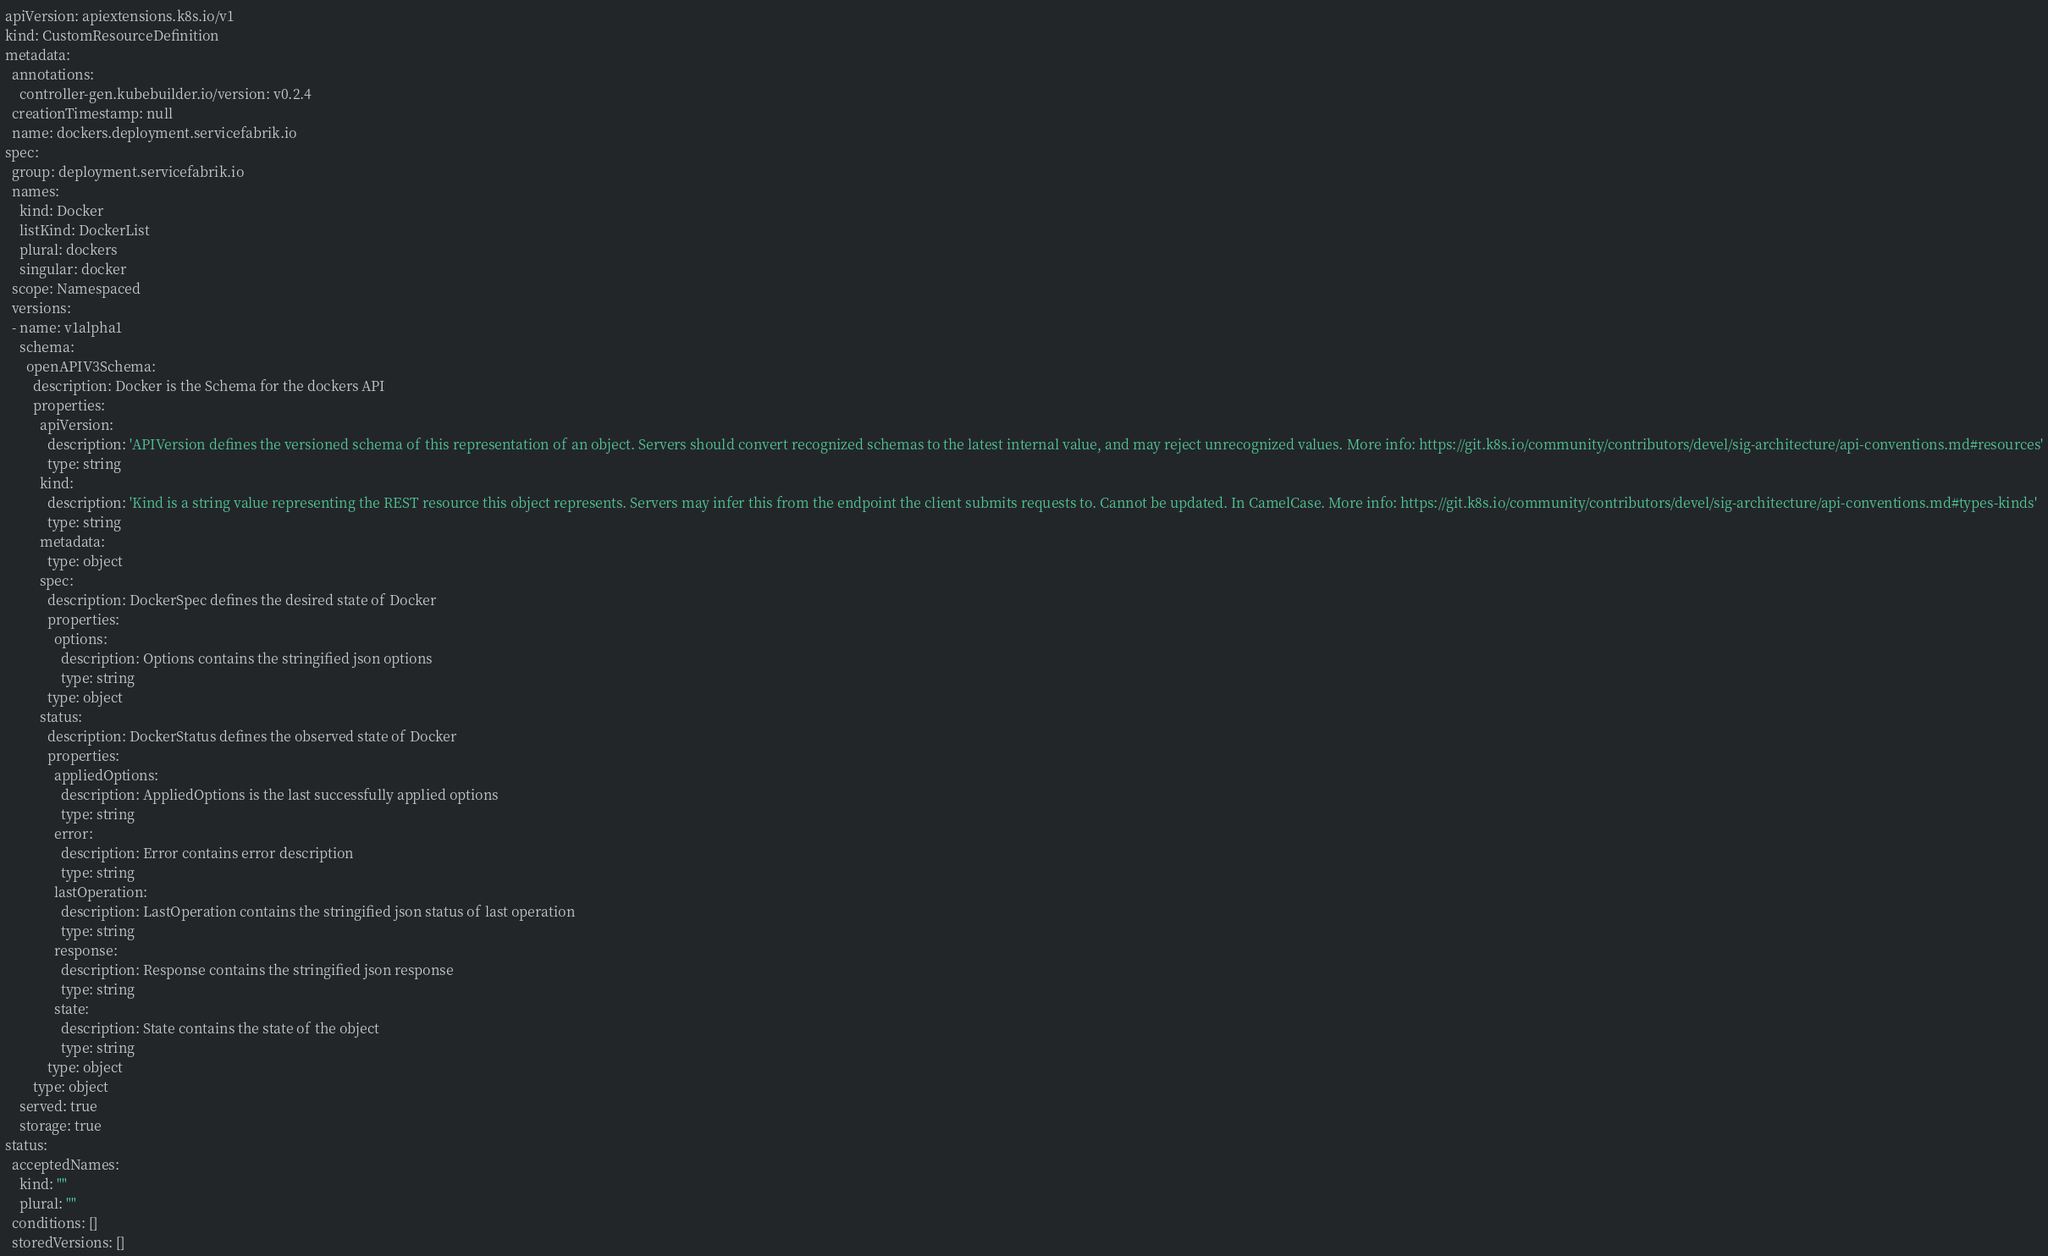Convert code to text. <code><loc_0><loc_0><loc_500><loc_500><_YAML_>apiVersion: apiextensions.k8s.io/v1
kind: CustomResourceDefinition
metadata:
  annotations:
    controller-gen.kubebuilder.io/version: v0.2.4
  creationTimestamp: null
  name: dockers.deployment.servicefabrik.io
spec:
  group: deployment.servicefabrik.io
  names:
    kind: Docker
    listKind: DockerList
    plural: dockers
    singular: docker
  scope: Namespaced
  versions:
  - name: v1alpha1
    schema:
      openAPIV3Schema:
        description: Docker is the Schema for the dockers API
        properties:
          apiVersion:
            description: 'APIVersion defines the versioned schema of this representation of an object. Servers should convert recognized schemas to the latest internal value, and may reject unrecognized values. More info: https://git.k8s.io/community/contributors/devel/sig-architecture/api-conventions.md#resources'
            type: string
          kind:
            description: 'Kind is a string value representing the REST resource this object represents. Servers may infer this from the endpoint the client submits requests to. Cannot be updated. In CamelCase. More info: https://git.k8s.io/community/contributors/devel/sig-architecture/api-conventions.md#types-kinds'
            type: string
          metadata:
            type: object
          spec:
            description: DockerSpec defines the desired state of Docker
            properties:
              options:
                description: Options contains the stringified json options
                type: string
            type: object
          status:
            description: DockerStatus defines the observed state of Docker
            properties:
              appliedOptions:
                description: AppliedOptions is the last successfully applied options
                type: string
              error:
                description: Error contains error description
                type: string
              lastOperation:
                description: LastOperation contains the stringified json status of last operation
                type: string
              response:
                description: Response contains the stringified json response
                type: string
              state:
                description: State contains the state of the object
                type: string
            type: object
        type: object
    served: true
    storage: true
status:
  acceptedNames:
    kind: ""
    plural: ""
  conditions: []
  storedVersions: []</code> 